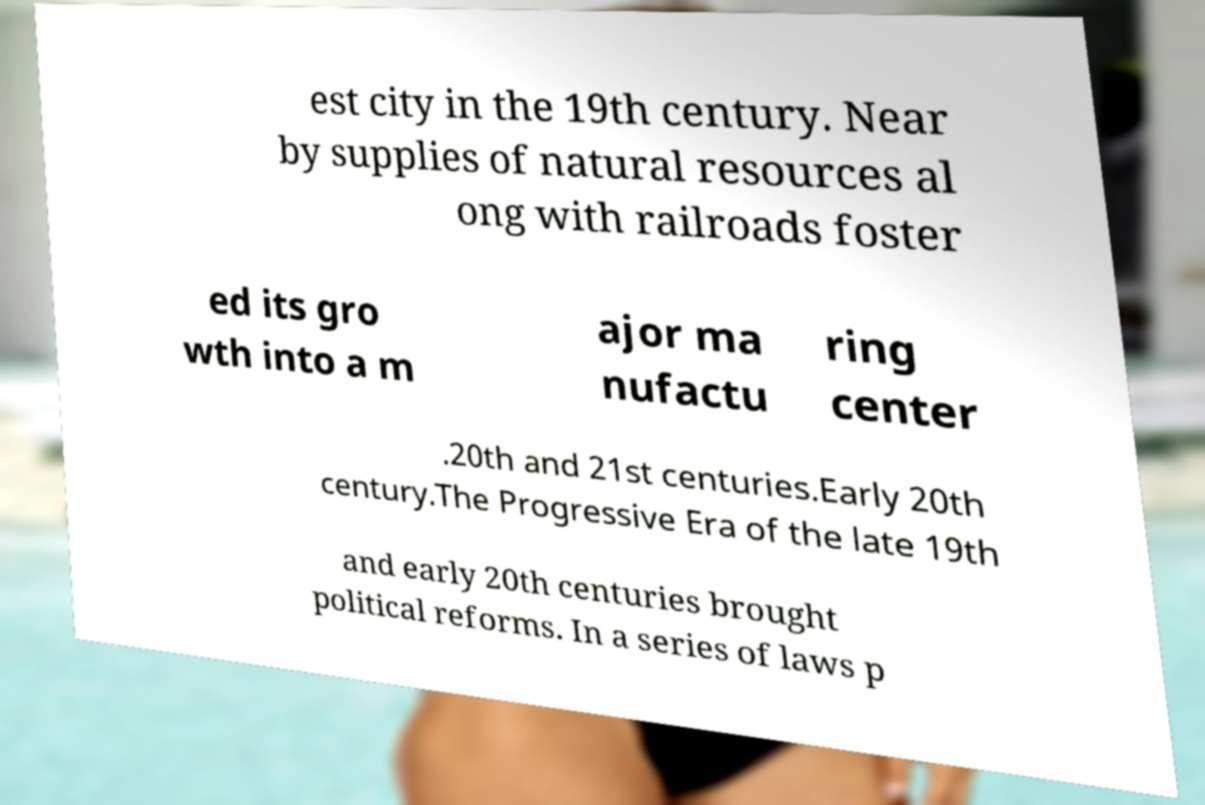There's text embedded in this image that I need extracted. Can you transcribe it verbatim? est city in the 19th century. Near by supplies of natural resources al ong with railroads foster ed its gro wth into a m ajor ma nufactu ring center .20th and 21st centuries.Early 20th century.The Progressive Era of the late 19th and early 20th centuries brought political reforms. In a series of laws p 